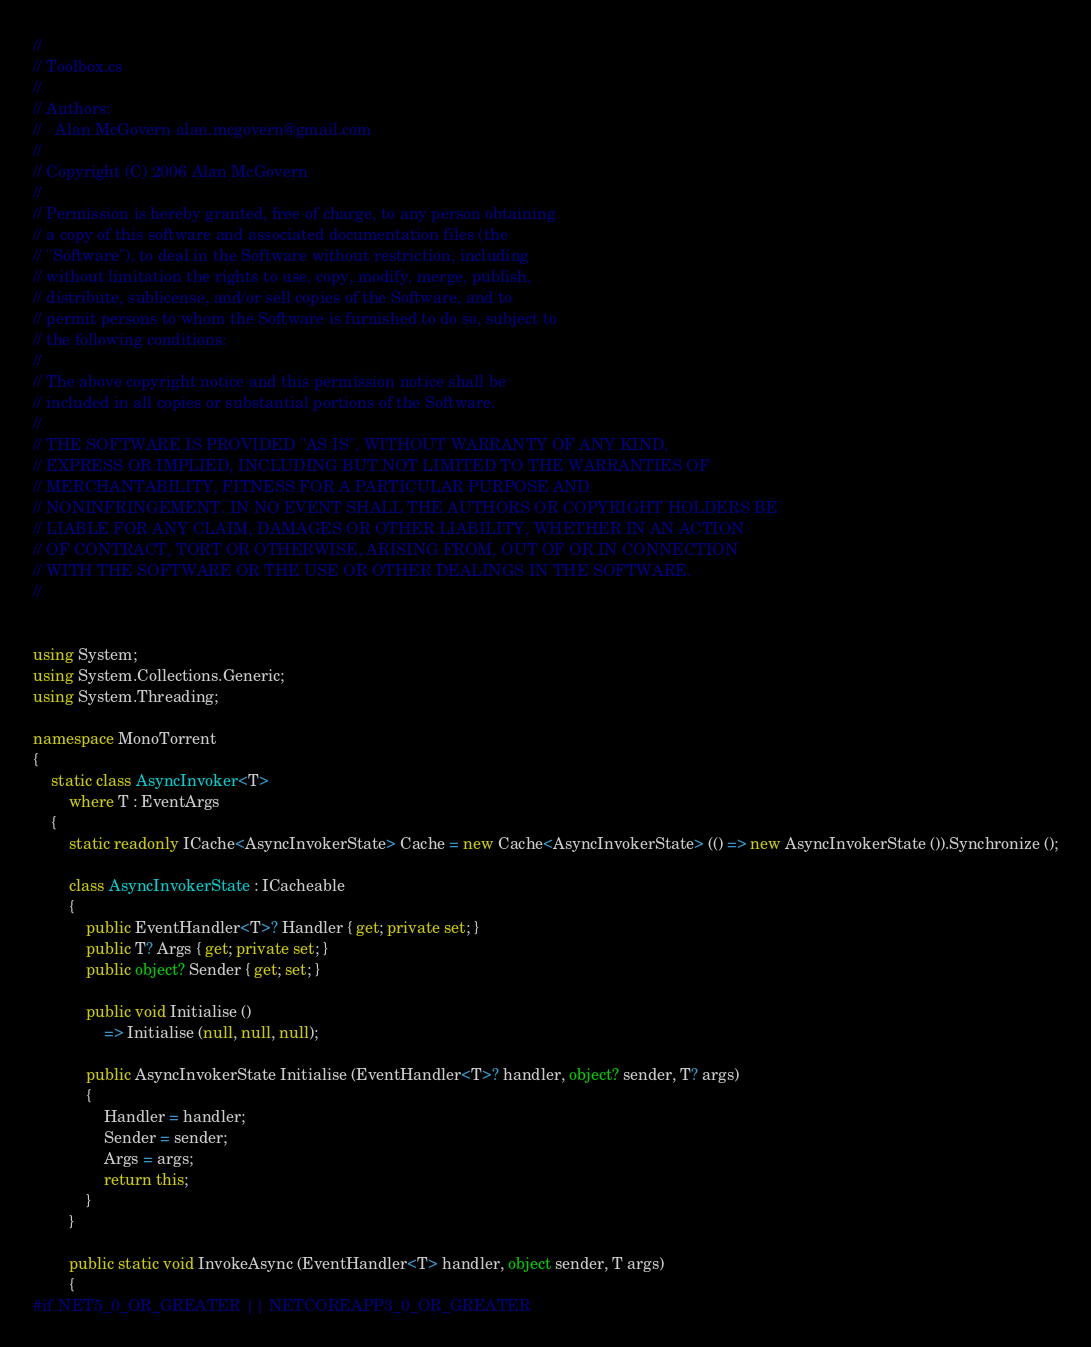<code> <loc_0><loc_0><loc_500><loc_500><_C#_>//
// Toolbox.cs
//
// Authors:
//   Alan McGovern alan.mcgovern@gmail.com
//
// Copyright (C) 2006 Alan McGovern
//
// Permission is hereby granted, free of charge, to any person obtaining
// a copy of this software and associated documentation files (the
// "Software"), to deal in the Software without restriction, including
// without limitation the rights to use, copy, modify, merge, publish,
// distribute, sublicense, and/or sell copies of the Software, and to
// permit persons to whom the Software is furnished to do so, subject to
// the following conditions:
// 
// The above copyright notice and this permission notice shall be
// included in all copies or substantial portions of the Software.
// 
// THE SOFTWARE IS PROVIDED "AS IS", WITHOUT WARRANTY OF ANY KIND,
// EXPRESS OR IMPLIED, INCLUDING BUT NOT LIMITED TO THE WARRANTIES OF
// MERCHANTABILITY, FITNESS FOR A PARTICULAR PURPOSE AND
// NONINFRINGEMENT. IN NO EVENT SHALL THE AUTHORS OR COPYRIGHT HOLDERS BE
// LIABLE FOR ANY CLAIM, DAMAGES OR OTHER LIABILITY, WHETHER IN AN ACTION
// OF CONTRACT, TORT OR OTHERWISE, ARISING FROM, OUT OF OR IN CONNECTION
// WITH THE SOFTWARE OR THE USE OR OTHER DEALINGS IN THE SOFTWARE.
//


using System;
using System.Collections.Generic;
using System.Threading;

namespace MonoTorrent
{
    static class AsyncInvoker<T>
        where T : EventArgs
    {
        static readonly ICache<AsyncInvokerState> Cache = new Cache<AsyncInvokerState> (() => new AsyncInvokerState ()).Synchronize ();

        class AsyncInvokerState : ICacheable
        {
            public EventHandler<T>? Handler { get; private set; }
            public T? Args { get; private set; }
            public object? Sender { get; set; }

            public void Initialise ()
                => Initialise (null, null, null);

            public AsyncInvokerState Initialise (EventHandler<T>? handler, object? sender, T? args)
            {
                Handler = handler;
                Sender = sender;
                Args = args;
                return this;
            }
        }

        public static void InvokeAsync (EventHandler<T> handler, object sender, T args)
        {
#if NET5_0_OR_GREATER || NETCOREAPP3_0_OR_GREATER</code> 